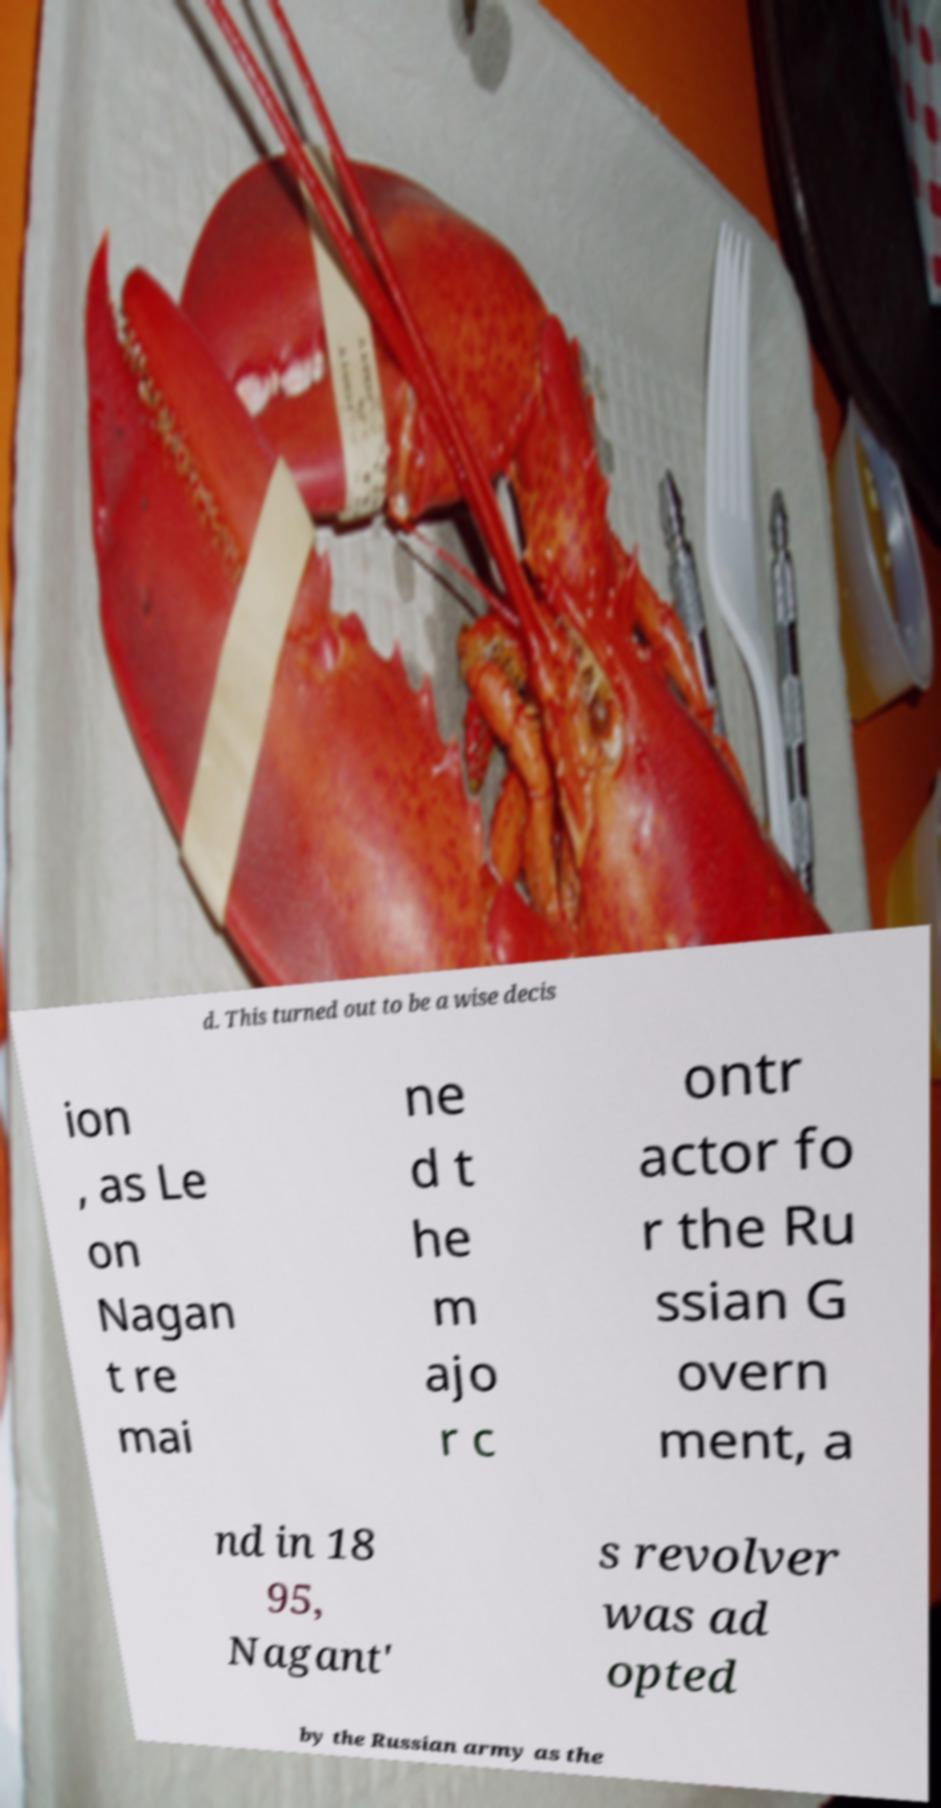There's text embedded in this image that I need extracted. Can you transcribe it verbatim? d. This turned out to be a wise decis ion , as Le on Nagan t re mai ne d t he m ajo r c ontr actor fo r the Ru ssian G overn ment, a nd in 18 95, Nagant' s revolver was ad opted by the Russian army as the 